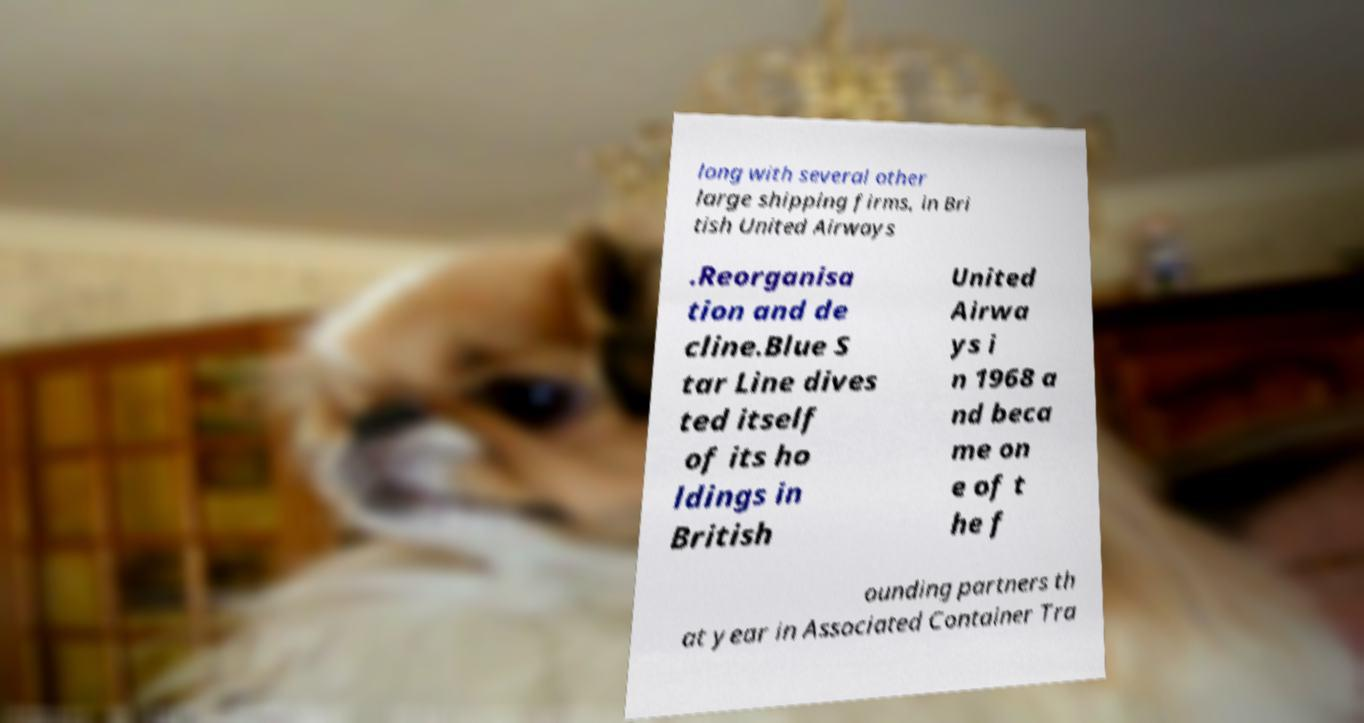What messages or text are displayed in this image? I need them in a readable, typed format. long with several other large shipping firms, in Bri tish United Airways .Reorganisa tion and de cline.Blue S tar Line dives ted itself of its ho ldings in British United Airwa ys i n 1968 a nd beca me on e of t he f ounding partners th at year in Associated Container Tra 